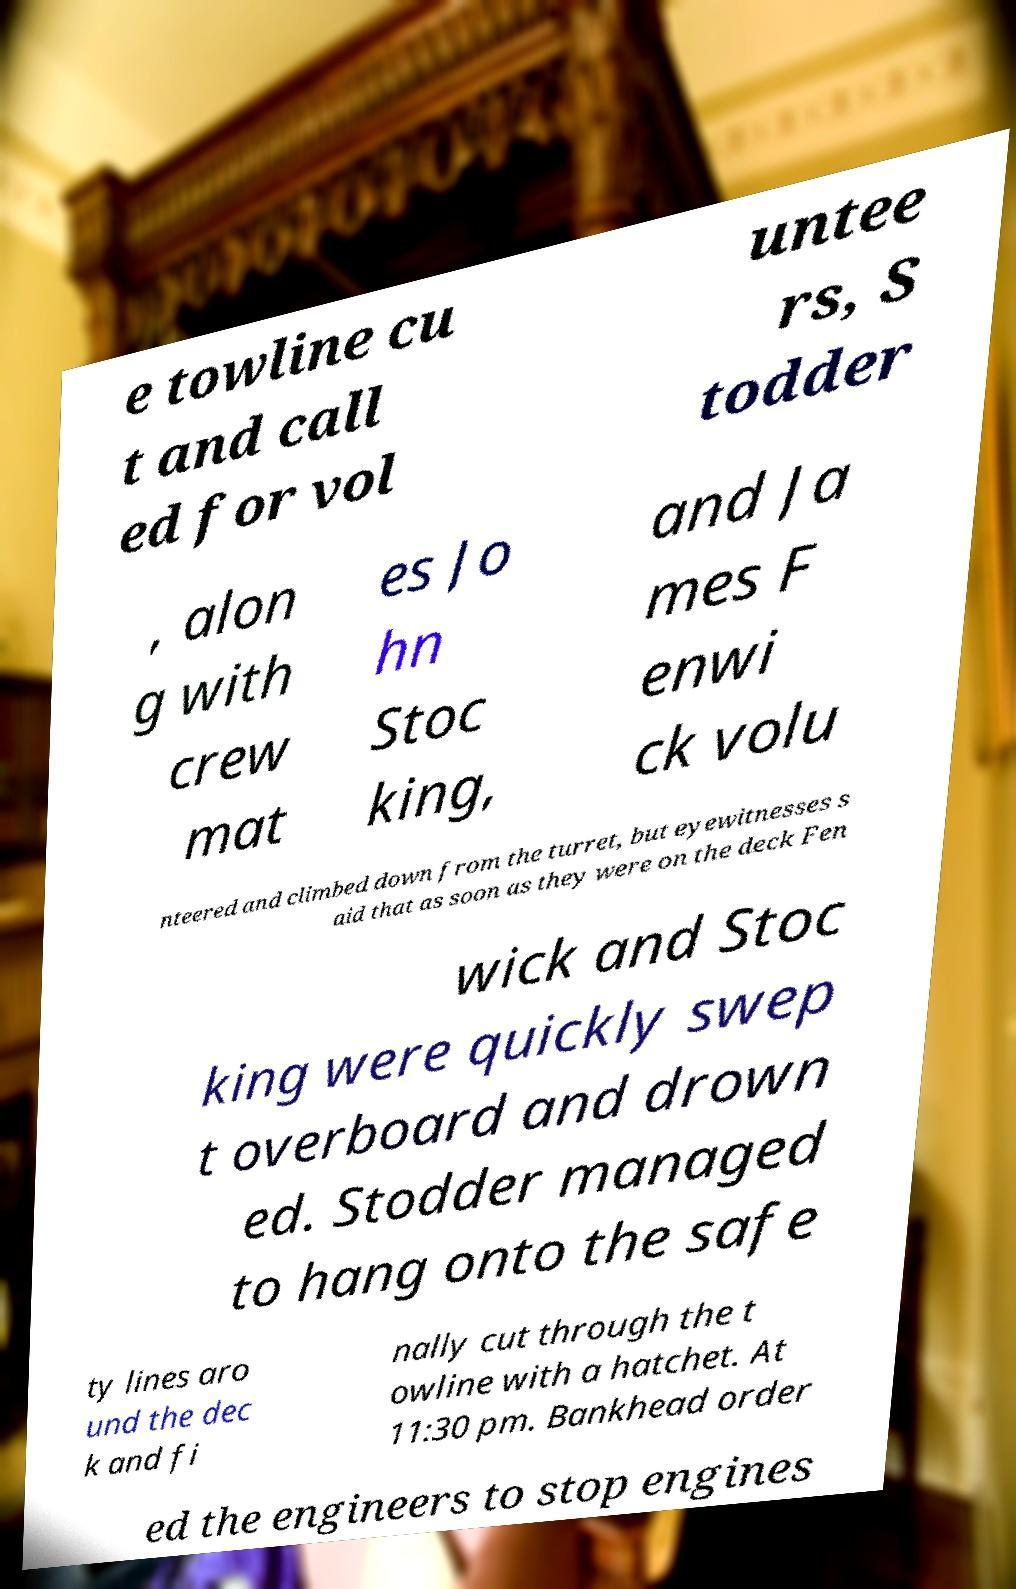Can you read and provide the text displayed in the image?This photo seems to have some interesting text. Can you extract and type it out for me? e towline cu t and call ed for vol untee rs, S todder , alon g with crew mat es Jo hn Stoc king, and Ja mes F enwi ck volu nteered and climbed down from the turret, but eyewitnesses s aid that as soon as they were on the deck Fen wick and Stoc king were quickly swep t overboard and drown ed. Stodder managed to hang onto the safe ty lines aro und the dec k and fi nally cut through the t owline with a hatchet. At 11:30 pm. Bankhead order ed the engineers to stop engines 